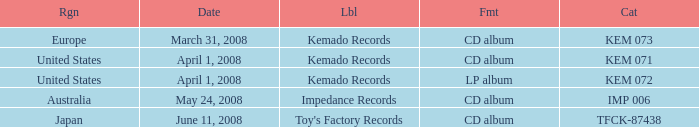Which Format has a Date of may 24, 2008? CD album. 